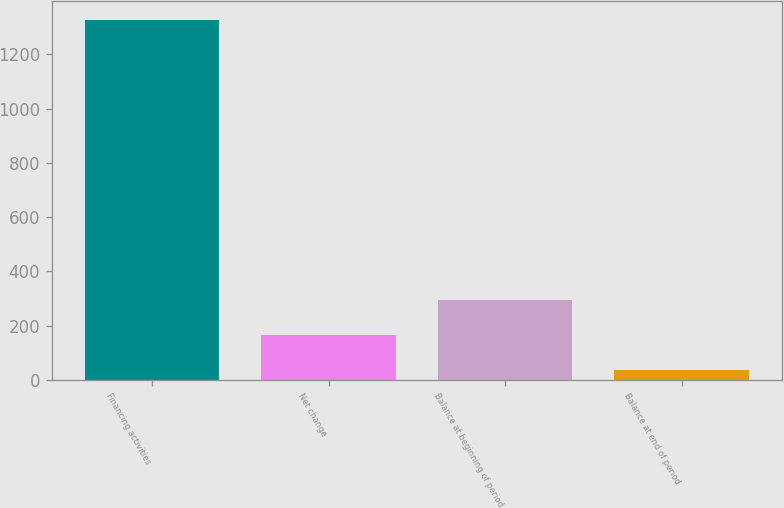Convert chart to OTSL. <chart><loc_0><loc_0><loc_500><loc_500><bar_chart><fcel>Financing activities<fcel>Net change<fcel>Balance at beginning of period<fcel>Balance at end of period<nl><fcel>1328<fcel>166.1<fcel>295.2<fcel>37<nl></chart> 